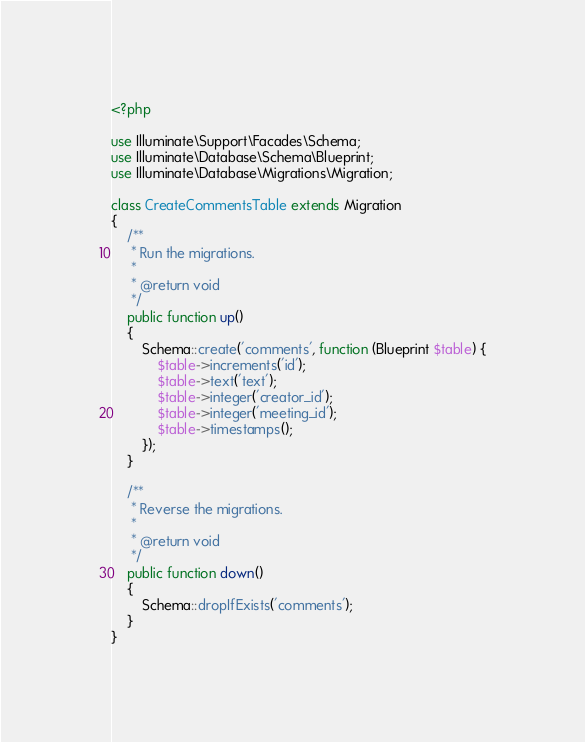Convert code to text. <code><loc_0><loc_0><loc_500><loc_500><_PHP_><?php

use Illuminate\Support\Facades\Schema;
use Illuminate\Database\Schema\Blueprint;
use Illuminate\Database\Migrations\Migration;

class CreateCommentsTable extends Migration
{
    /**
     * Run the migrations.
     *
     * @return void
     */
    public function up()
    {
        Schema::create('comments', function (Blueprint $table) {
            $table->increments('id');
            $table->text('text');
            $table->integer('creator_id');
            $table->integer('meeting_id');
            $table->timestamps();
        });
    }

    /**
     * Reverse the migrations.
     *
     * @return void
     */
    public function down()
    {
        Schema::dropIfExists('comments');
    }
}
</code> 